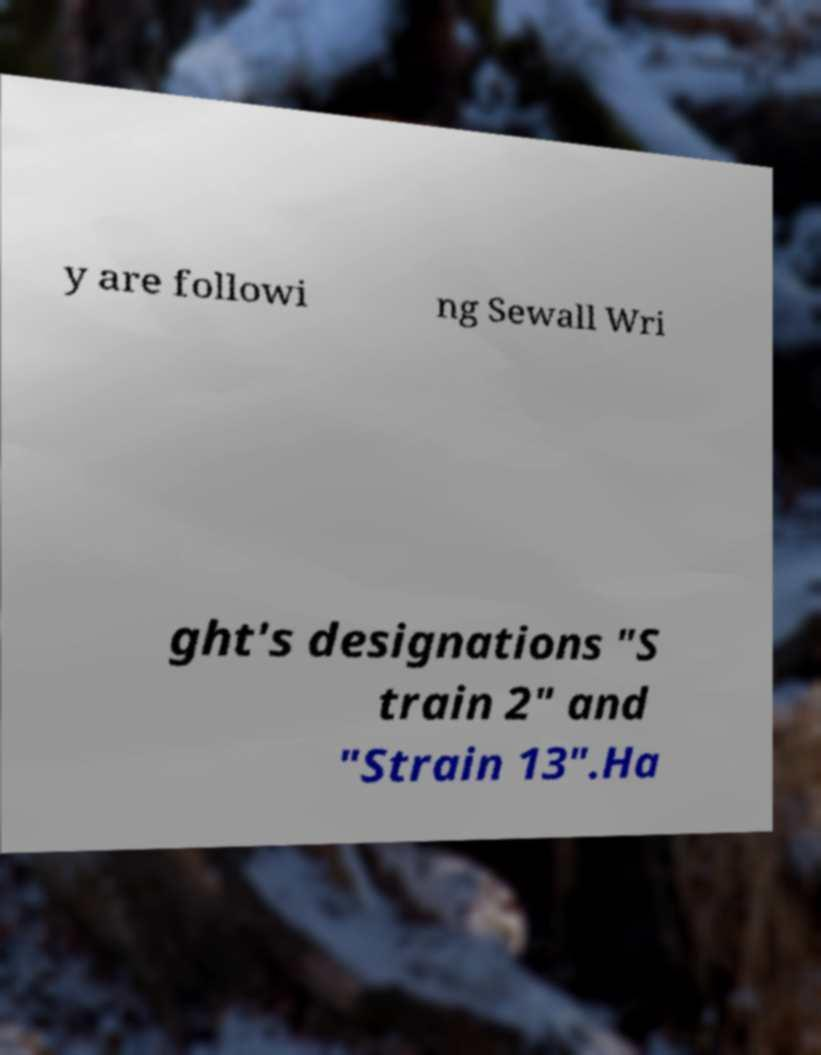Please read and relay the text visible in this image. What does it say? y are followi ng Sewall Wri ght's designations "S train 2" and "Strain 13".Ha 